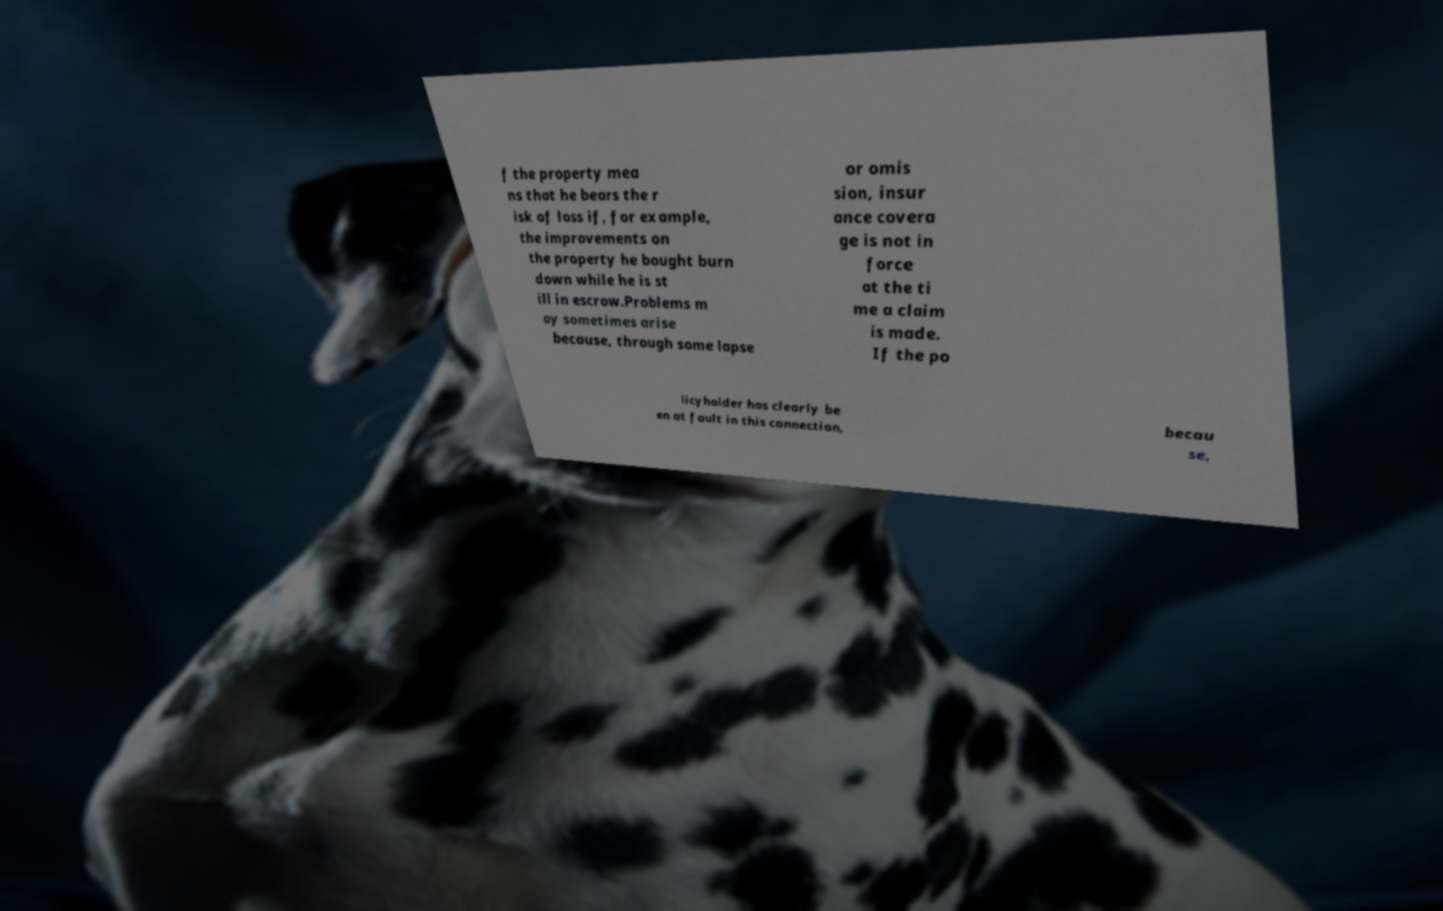For documentation purposes, I need the text within this image transcribed. Could you provide that? f the property mea ns that he bears the r isk of loss if, for example, the improvements on the property he bought burn down while he is st ill in escrow.Problems m ay sometimes arise because, through some lapse or omis sion, insur ance covera ge is not in force at the ti me a claim is made. If the po licyholder has clearly be en at fault in this connection, becau se, 